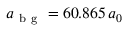<formula> <loc_0><loc_0><loc_500><loc_500>a _ { b g } = 6 0 . 8 6 5 \, a _ { 0 }</formula> 